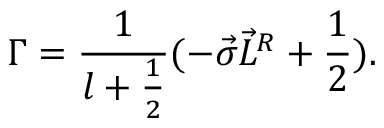Convert formula to latex. <formula><loc_0><loc_0><loc_500><loc_500>{ \Gamma } = \frac { 1 } { l + \frac { 1 } { 2 } } ( - \vec { \sigma } \vec { L } ^ { R } + \frac { 1 } { 2 } ) .</formula> 